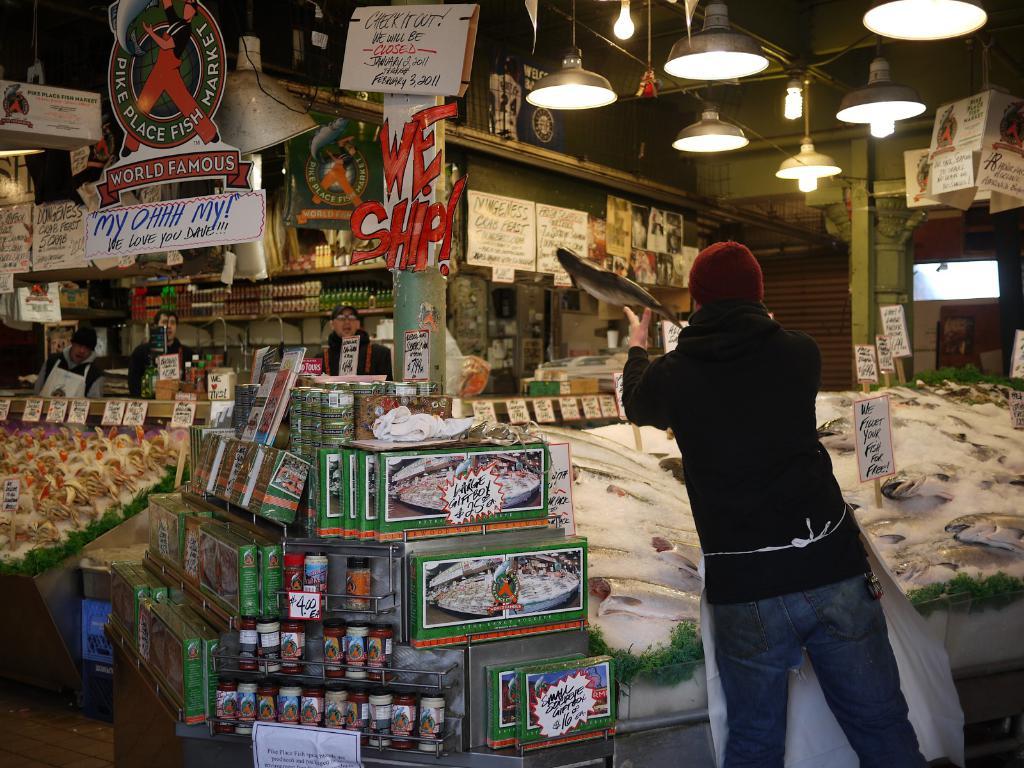Do they ship or don't they according to the sign?
Your response must be concise. Yes. What is the name of the market?
Provide a succinct answer. Pike place fish market. 